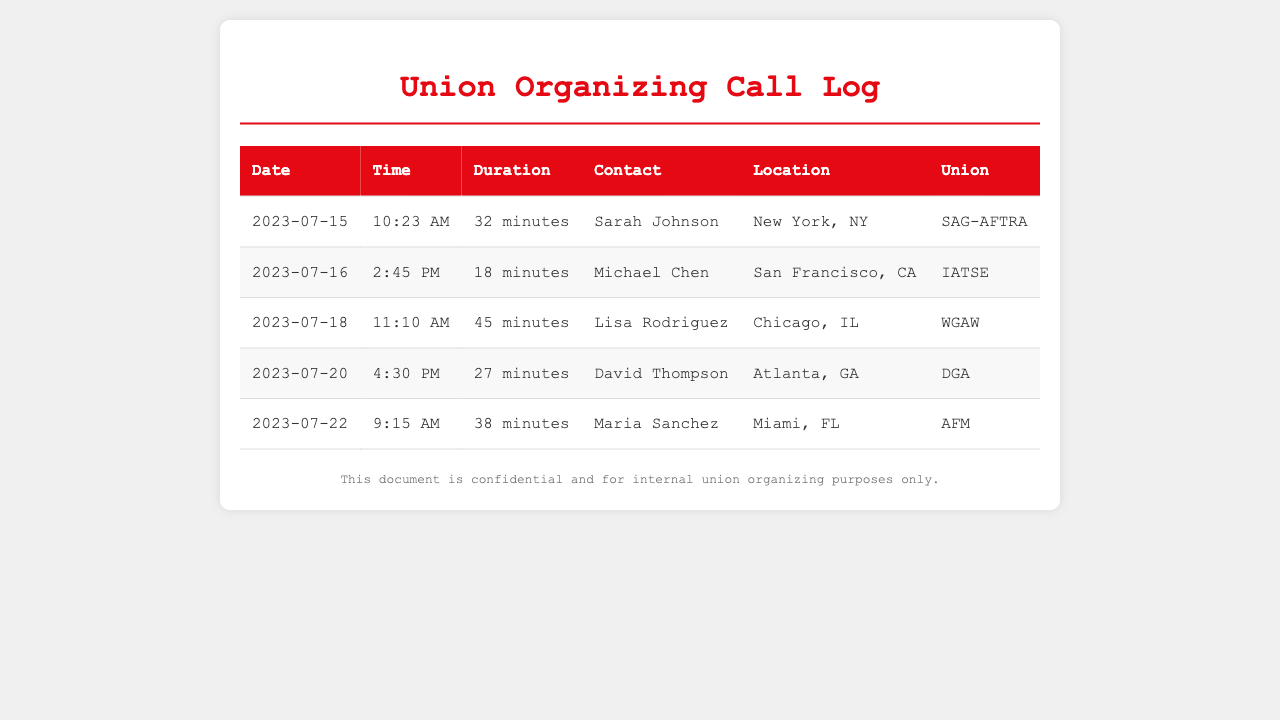what is the duration of the call with Lisa Rodriguez? The duration is listed in the table for the call made on July 18, which is 45 minutes.
Answer: 45 minutes who is the contact for the call on July 20? The contact for the call on July 20 is found in the table and is David Thompson.
Answer: David Thompson how many total calls are logged in this document? By counting the entries in the table, there are 5 calls logged.
Answer: 5 which location is associated with Maria Sanchez? The table shows that Maria Sanchez is located in Miami, FL.
Answer: Miami, FL what union does Michael Chen belong to? The union affiliation is noted in the table, indicating Michael Chen belongs to IATSE.
Answer: IATSE on which date was the longest call made? Analyzing the durations, the longest call of 45 minutes was made on July 18.
Answer: July 18 how many minutes was the call with Sarah Johnson? The table specifies that the call with Sarah Johnson lasted for 32 minutes.
Answer: 32 minutes who made the call on July 22? The table lists that the call on July 22 was made by Maria Sanchez.
Answer: Maria Sanchez 